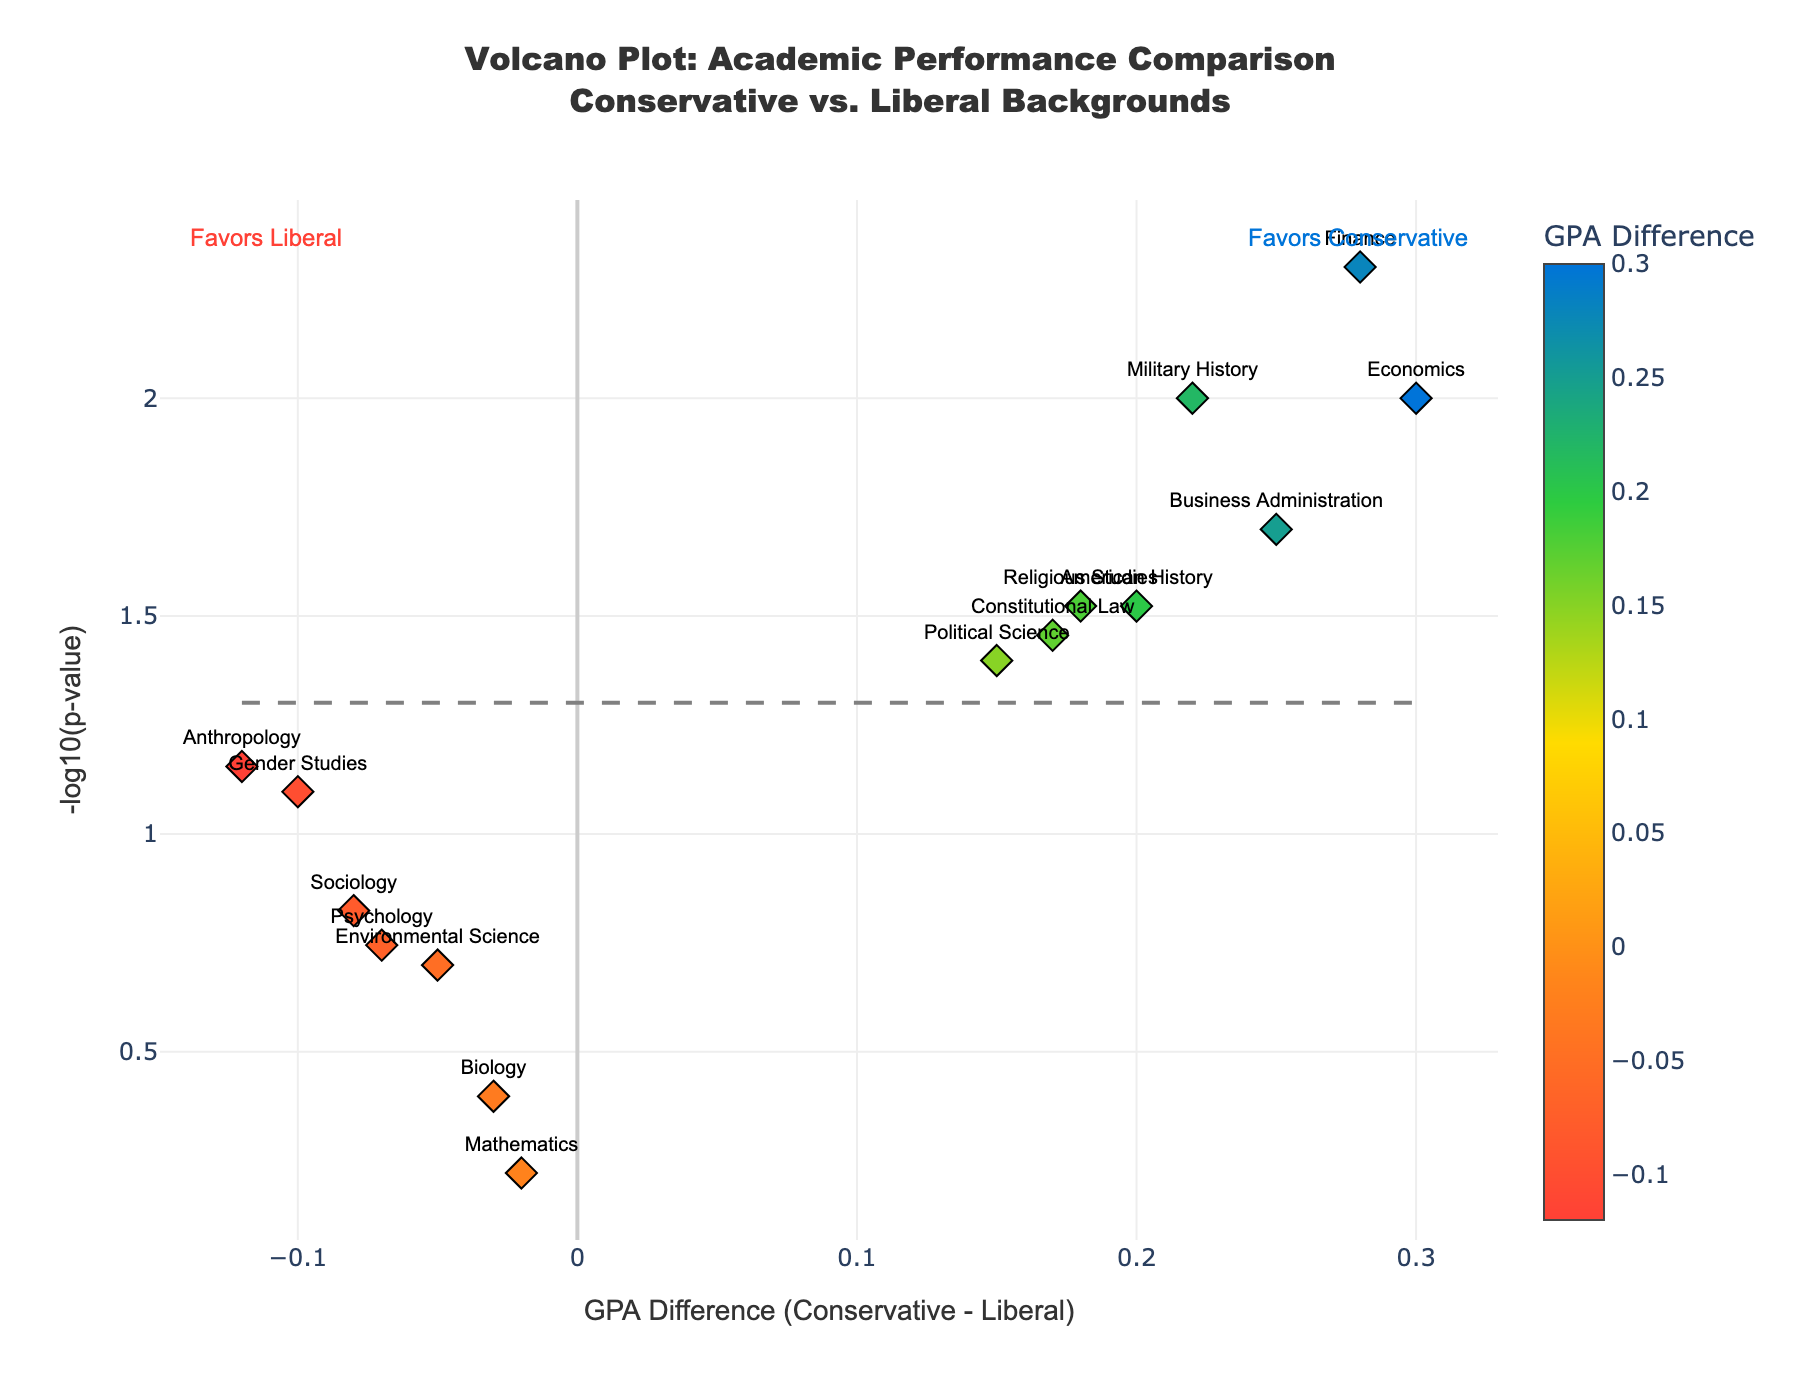What is the range of GPA differences shown on the plot? The GPA differences shown on the plot range from a minimum of -0.12 to a maximum of 0.3. To find this, we look at the x-axis of the plot, which represents the GPA differences.
Answer: -0.12 to 0.3 How many subjects show a statistically significant difference in GPA (P-value < 0.05)? To determine how many subjects show a statistically significant difference in GPA, we count the number of points above the significance threshold line, which corresponds to -log10(0.05). There are 8 points above this line.
Answer: 8 Which subject has the highest GPA difference favoring students from conservative backgrounds? Finance has the highest GPA difference favoring conservative backgrounds. This information can be deduced by identifying the data point farthest to the right on the plot, which represents the highest positive GPA difference.
Answer: Finance What subjects have a negative GPA difference and are also statistically significant? To find subjects with negative GPA differences and statistically significant P-values, we look at data points on the left of the x-axis and above the significance threshold line. There are no subjects that meet both criteria.
Answer: None What is the P-value threshold used to determine statistical significance in the plot? The P-value threshold is the cut-off value used to determine if a result is statistically significant. The line representing statistical significance on the plot corresponds to -log10(0.05), meaning the threshold P-value is 0.05.
Answer: 0.05 Which subject has the highest -log10(P-value) and what does it indicate? The subject with the highest -log10(P-value) is Finance. The higher value indicates a very low P-value, suggesting a strong statistical significance in the GPA difference for Finance.
Answer: Finance By how much does the GPA difference for Economics exceed that of Political Science? To find the answer, subtract the GPA difference of Political Science (0.15) from that of Economics (0.3): 0.3 - 0.15 equals 0.15. Economics exceeds Political Science by 0.15 in GPA difference.
Answer: 0.15 Which subjects have a GPA difference between 0.1 and 0.2 inclusive? To find the subjects within this GPA difference range, we locate the data points between 0.1 and 0.2 on the x-axis. These subjects are Political Science, Religious Studies, and Constitutional Law.
Answer: Political Science, Religious Studies, Constitutional Law Compared to American History, which subject has a P-value closest to 0.03 but a larger GPA difference? To solve this, identify subjects with P-values around 0.03. American History has a P-value of 0.03 and a GPA difference of 0.2. Religious Studies also has a P-value of 0.03 but a GPA difference of 0.18, which is smaller. Hence, American History does not have a subject that matches the criteria perfectly.
Answer: None 